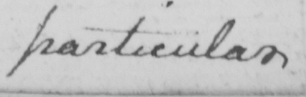Please provide the text content of this handwritten line. particular 